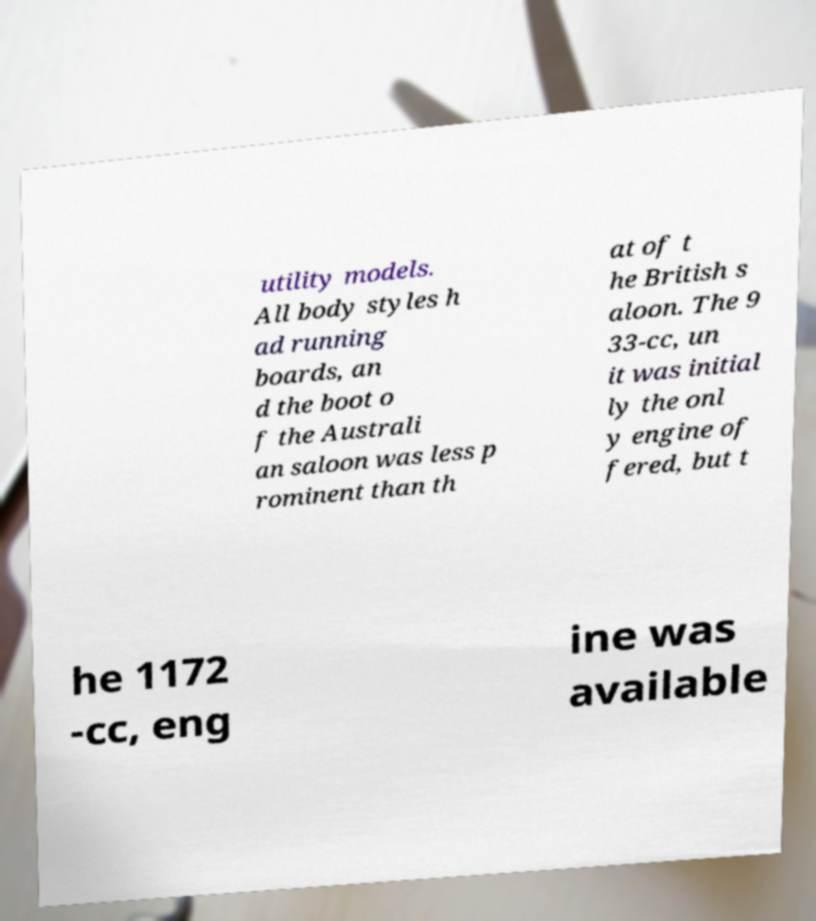What messages or text are displayed in this image? I need them in a readable, typed format. utility models. All body styles h ad running boards, an d the boot o f the Australi an saloon was less p rominent than th at of t he British s aloon. The 9 33-cc, un it was initial ly the onl y engine of fered, but t he 1172 -cc, eng ine was available 